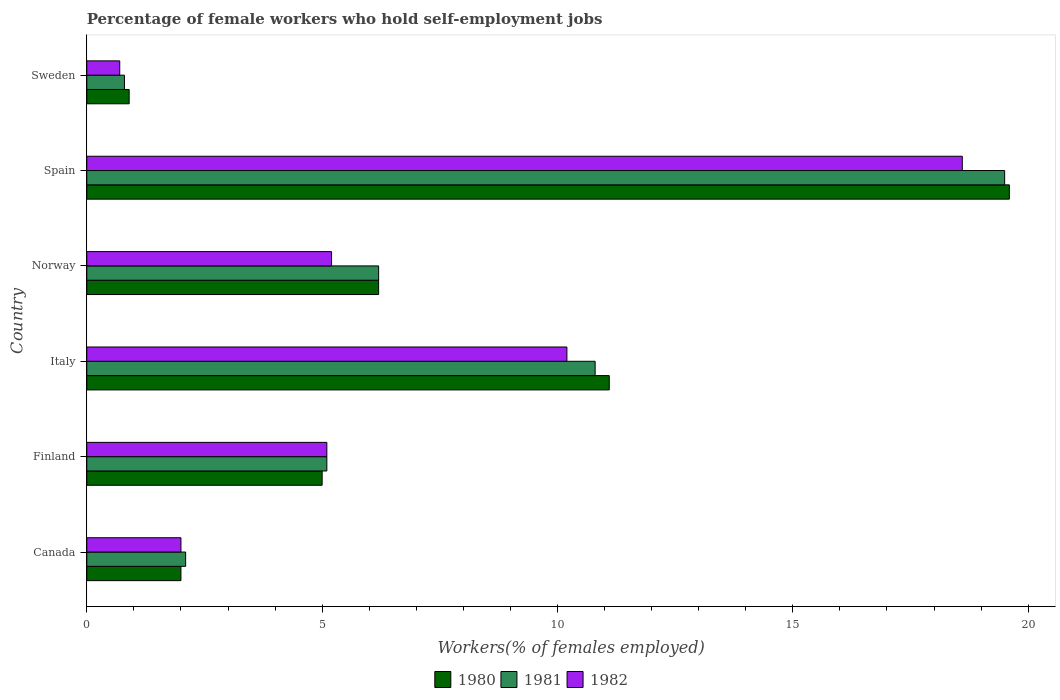How many different coloured bars are there?
Make the answer very short. 3. Are the number of bars per tick equal to the number of legend labels?
Provide a succinct answer. Yes. Are the number of bars on each tick of the Y-axis equal?
Keep it short and to the point. Yes. Across all countries, what is the maximum percentage of self-employed female workers in 1981?
Provide a succinct answer. 19.5. Across all countries, what is the minimum percentage of self-employed female workers in 1980?
Offer a terse response. 0.9. In which country was the percentage of self-employed female workers in 1981 minimum?
Make the answer very short. Sweden. What is the total percentage of self-employed female workers in 1982 in the graph?
Your response must be concise. 41.8. What is the difference between the percentage of self-employed female workers in 1981 in Canada and that in Norway?
Provide a short and direct response. -4.1. What is the difference between the percentage of self-employed female workers in 1980 in Spain and the percentage of self-employed female workers in 1982 in Sweden?
Keep it short and to the point. 18.9. What is the average percentage of self-employed female workers in 1981 per country?
Offer a terse response. 7.42. What is the difference between the percentage of self-employed female workers in 1980 and percentage of self-employed female workers in 1982 in Norway?
Your answer should be very brief. 1. What is the ratio of the percentage of self-employed female workers in 1980 in Norway to that in Spain?
Your answer should be very brief. 0.32. Is the percentage of self-employed female workers in 1980 in Canada less than that in Sweden?
Make the answer very short. No. Is the difference between the percentage of self-employed female workers in 1980 in Norway and Spain greater than the difference between the percentage of self-employed female workers in 1982 in Norway and Spain?
Give a very brief answer. Yes. What is the difference between the highest and the second highest percentage of self-employed female workers in 1982?
Make the answer very short. 8.4. What is the difference between the highest and the lowest percentage of self-employed female workers in 1980?
Your answer should be very brief. 18.7. What does the 1st bar from the top in Finland represents?
Provide a succinct answer. 1982. Is it the case that in every country, the sum of the percentage of self-employed female workers in 1982 and percentage of self-employed female workers in 1980 is greater than the percentage of self-employed female workers in 1981?
Your answer should be very brief. Yes. How many bars are there?
Provide a succinct answer. 18. Are the values on the major ticks of X-axis written in scientific E-notation?
Keep it short and to the point. No. Where does the legend appear in the graph?
Provide a succinct answer. Bottom center. How many legend labels are there?
Make the answer very short. 3. How are the legend labels stacked?
Ensure brevity in your answer.  Horizontal. What is the title of the graph?
Offer a very short reply. Percentage of female workers who hold self-employment jobs. Does "1960" appear as one of the legend labels in the graph?
Your response must be concise. No. What is the label or title of the X-axis?
Give a very brief answer. Workers(% of females employed). What is the Workers(% of females employed) of 1981 in Canada?
Your response must be concise. 2.1. What is the Workers(% of females employed) in 1982 in Canada?
Your response must be concise. 2. What is the Workers(% of females employed) of 1980 in Finland?
Your answer should be compact. 5. What is the Workers(% of females employed) of 1981 in Finland?
Provide a short and direct response. 5.1. What is the Workers(% of females employed) in 1982 in Finland?
Offer a very short reply. 5.1. What is the Workers(% of females employed) of 1980 in Italy?
Your answer should be compact. 11.1. What is the Workers(% of females employed) of 1981 in Italy?
Give a very brief answer. 10.8. What is the Workers(% of females employed) of 1982 in Italy?
Your answer should be compact. 10.2. What is the Workers(% of females employed) of 1980 in Norway?
Ensure brevity in your answer.  6.2. What is the Workers(% of females employed) in 1981 in Norway?
Your answer should be very brief. 6.2. What is the Workers(% of females employed) in 1982 in Norway?
Offer a terse response. 5.2. What is the Workers(% of females employed) of 1980 in Spain?
Provide a short and direct response. 19.6. What is the Workers(% of females employed) in 1982 in Spain?
Your answer should be compact. 18.6. What is the Workers(% of females employed) in 1980 in Sweden?
Your answer should be compact. 0.9. What is the Workers(% of females employed) in 1981 in Sweden?
Provide a succinct answer. 0.8. What is the Workers(% of females employed) in 1982 in Sweden?
Keep it short and to the point. 0.7. Across all countries, what is the maximum Workers(% of females employed) in 1980?
Your answer should be very brief. 19.6. Across all countries, what is the maximum Workers(% of females employed) of 1981?
Give a very brief answer. 19.5. Across all countries, what is the maximum Workers(% of females employed) of 1982?
Your answer should be compact. 18.6. Across all countries, what is the minimum Workers(% of females employed) in 1980?
Give a very brief answer. 0.9. Across all countries, what is the minimum Workers(% of females employed) in 1981?
Provide a succinct answer. 0.8. Across all countries, what is the minimum Workers(% of females employed) of 1982?
Your response must be concise. 0.7. What is the total Workers(% of females employed) in 1980 in the graph?
Ensure brevity in your answer.  44.8. What is the total Workers(% of females employed) in 1981 in the graph?
Give a very brief answer. 44.5. What is the total Workers(% of females employed) of 1982 in the graph?
Give a very brief answer. 41.8. What is the difference between the Workers(% of females employed) of 1980 in Canada and that in Finland?
Provide a short and direct response. -3. What is the difference between the Workers(% of females employed) of 1982 in Canada and that in Finland?
Your answer should be very brief. -3.1. What is the difference between the Workers(% of females employed) of 1980 in Canada and that in Italy?
Ensure brevity in your answer.  -9.1. What is the difference between the Workers(% of females employed) of 1981 in Canada and that in Italy?
Your response must be concise. -8.7. What is the difference between the Workers(% of females employed) of 1982 in Canada and that in Italy?
Ensure brevity in your answer.  -8.2. What is the difference between the Workers(% of females employed) of 1981 in Canada and that in Norway?
Offer a terse response. -4.1. What is the difference between the Workers(% of females employed) in 1980 in Canada and that in Spain?
Your response must be concise. -17.6. What is the difference between the Workers(% of females employed) in 1981 in Canada and that in Spain?
Give a very brief answer. -17.4. What is the difference between the Workers(% of females employed) in 1982 in Canada and that in Spain?
Make the answer very short. -16.6. What is the difference between the Workers(% of females employed) of 1981 in Canada and that in Sweden?
Keep it short and to the point. 1.3. What is the difference between the Workers(% of females employed) of 1982 in Canada and that in Sweden?
Ensure brevity in your answer.  1.3. What is the difference between the Workers(% of females employed) of 1980 in Finland and that in Italy?
Your answer should be compact. -6.1. What is the difference between the Workers(% of females employed) in 1982 in Finland and that in Italy?
Offer a very short reply. -5.1. What is the difference between the Workers(% of females employed) of 1980 in Finland and that in Spain?
Offer a terse response. -14.6. What is the difference between the Workers(% of females employed) of 1981 in Finland and that in Spain?
Your answer should be compact. -14.4. What is the difference between the Workers(% of females employed) in 1982 in Finland and that in Spain?
Provide a short and direct response. -13.5. What is the difference between the Workers(% of females employed) of 1980 in Finland and that in Sweden?
Keep it short and to the point. 4.1. What is the difference between the Workers(% of females employed) in 1982 in Finland and that in Sweden?
Keep it short and to the point. 4.4. What is the difference between the Workers(% of females employed) in 1980 in Italy and that in Norway?
Provide a short and direct response. 4.9. What is the difference between the Workers(% of females employed) in 1981 in Italy and that in Norway?
Provide a short and direct response. 4.6. What is the difference between the Workers(% of females employed) in 1980 in Italy and that in Spain?
Your answer should be very brief. -8.5. What is the difference between the Workers(% of females employed) of 1981 in Italy and that in Spain?
Your response must be concise. -8.7. What is the difference between the Workers(% of females employed) of 1980 in Italy and that in Sweden?
Provide a succinct answer. 10.2. What is the difference between the Workers(% of females employed) of 1982 in Italy and that in Sweden?
Provide a short and direct response. 9.5. What is the difference between the Workers(% of females employed) of 1980 in Norway and that in Spain?
Ensure brevity in your answer.  -13.4. What is the difference between the Workers(% of females employed) in 1981 in Norway and that in Spain?
Your response must be concise. -13.3. What is the difference between the Workers(% of females employed) in 1981 in Spain and that in Sweden?
Your response must be concise. 18.7. What is the difference between the Workers(% of females employed) in 1980 in Canada and the Workers(% of females employed) in 1981 in Finland?
Give a very brief answer. -3.1. What is the difference between the Workers(% of females employed) of 1980 in Canada and the Workers(% of females employed) of 1982 in Finland?
Ensure brevity in your answer.  -3.1. What is the difference between the Workers(% of females employed) of 1981 in Canada and the Workers(% of females employed) of 1982 in Finland?
Keep it short and to the point. -3. What is the difference between the Workers(% of females employed) in 1980 in Canada and the Workers(% of females employed) in 1982 in Italy?
Your response must be concise. -8.2. What is the difference between the Workers(% of females employed) in 1980 in Canada and the Workers(% of females employed) in 1982 in Norway?
Make the answer very short. -3.2. What is the difference between the Workers(% of females employed) in 1981 in Canada and the Workers(% of females employed) in 1982 in Norway?
Provide a succinct answer. -3.1. What is the difference between the Workers(% of females employed) in 1980 in Canada and the Workers(% of females employed) in 1981 in Spain?
Provide a succinct answer. -17.5. What is the difference between the Workers(% of females employed) of 1980 in Canada and the Workers(% of females employed) of 1982 in Spain?
Your answer should be very brief. -16.6. What is the difference between the Workers(% of females employed) of 1981 in Canada and the Workers(% of females employed) of 1982 in Spain?
Ensure brevity in your answer.  -16.5. What is the difference between the Workers(% of females employed) of 1980 in Canada and the Workers(% of females employed) of 1982 in Sweden?
Ensure brevity in your answer.  1.3. What is the difference between the Workers(% of females employed) in 1980 in Finland and the Workers(% of females employed) in 1981 in Italy?
Ensure brevity in your answer.  -5.8. What is the difference between the Workers(% of females employed) of 1980 in Finland and the Workers(% of females employed) of 1982 in Italy?
Provide a short and direct response. -5.2. What is the difference between the Workers(% of females employed) in 1981 in Finland and the Workers(% of females employed) in 1982 in Italy?
Ensure brevity in your answer.  -5.1. What is the difference between the Workers(% of females employed) in 1980 in Finland and the Workers(% of females employed) in 1982 in Norway?
Your response must be concise. -0.2. What is the difference between the Workers(% of females employed) in 1981 in Finland and the Workers(% of females employed) in 1982 in Norway?
Provide a short and direct response. -0.1. What is the difference between the Workers(% of females employed) in 1980 in Finland and the Workers(% of females employed) in 1982 in Sweden?
Keep it short and to the point. 4.3. What is the difference between the Workers(% of females employed) in 1981 in Finland and the Workers(% of females employed) in 1982 in Sweden?
Your answer should be very brief. 4.4. What is the difference between the Workers(% of females employed) of 1980 in Italy and the Workers(% of females employed) of 1981 in Norway?
Offer a terse response. 4.9. What is the difference between the Workers(% of females employed) of 1980 in Italy and the Workers(% of females employed) of 1982 in Norway?
Your answer should be compact. 5.9. What is the difference between the Workers(% of females employed) of 1981 in Italy and the Workers(% of females employed) of 1982 in Norway?
Offer a terse response. 5.6. What is the difference between the Workers(% of females employed) in 1980 in Italy and the Workers(% of females employed) in 1981 in Spain?
Give a very brief answer. -8.4. What is the difference between the Workers(% of females employed) of 1981 in Italy and the Workers(% of females employed) of 1982 in Spain?
Offer a very short reply. -7.8. What is the difference between the Workers(% of females employed) of 1980 in Italy and the Workers(% of females employed) of 1981 in Sweden?
Keep it short and to the point. 10.3. What is the difference between the Workers(% of females employed) in 1980 in Italy and the Workers(% of females employed) in 1982 in Sweden?
Your answer should be very brief. 10.4. What is the difference between the Workers(% of females employed) in 1980 in Norway and the Workers(% of females employed) in 1981 in Spain?
Your answer should be compact. -13.3. What is the difference between the Workers(% of females employed) of 1980 in Spain and the Workers(% of females employed) of 1981 in Sweden?
Provide a short and direct response. 18.8. What is the difference between the Workers(% of females employed) in 1980 in Spain and the Workers(% of females employed) in 1982 in Sweden?
Your answer should be very brief. 18.9. What is the difference between the Workers(% of females employed) in 1981 in Spain and the Workers(% of females employed) in 1982 in Sweden?
Ensure brevity in your answer.  18.8. What is the average Workers(% of females employed) of 1980 per country?
Make the answer very short. 7.47. What is the average Workers(% of females employed) in 1981 per country?
Your response must be concise. 7.42. What is the average Workers(% of females employed) in 1982 per country?
Your answer should be very brief. 6.97. What is the difference between the Workers(% of females employed) of 1980 and Workers(% of females employed) of 1982 in Canada?
Offer a very short reply. 0. What is the difference between the Workers(% of females employed) in 1980 and Workers(% of females employed) in 1982 in Finland?
Offer a terse response. -0.1. What is the difference between the Workers(% of females employed) of 1981 and Workers(% of females employed) of 1982 in Finland?
Your answer should be compact. 0. What is the difference between the Workers(% of females employed) in 1980 and Workers(% of females employed) in 1982 in Italy?
Make the answer very short. 0.9. What is the difference between the Workers(% of females employed) in 1981 and Workers(% of females employed) in 1982 in Italy?
Provide a short and direct response. 0.6. What is the difference between the Workers(% of females employed) in 1981 and Workers(% of females employed) in 1982 in Norway?
Keep it short and to the point. 1. What is the difference between the Workers(% of females employed) in 1980 and Workers(% of females employed) in 1981 in Spain?
Give a very brief answer. 0.1. What is the difference between the Workers(% of females employed) of 1981 and Workers(% of females employed) of 1982 in Spain?
Your answer should be very brief. 0.9. What is the difference between the Workers(% of females employed) of 1980 and Workers(% of females employed) of 1982 in Sweden?
Give a very brief answer. 0.2. What is the ratio of the Workers(% of females employed) of 1980 in Canada to that in Finland?
Make the answer very short. 0.4. What is the ratio of the Workers(% of females employed) of 1981 in Canada to that in Finland?
Offer a very short reply. 0.41. What is the ratio of the Workers(% of females employed) of 1982 in Canada to that in Finland?
Make the answer very short. 0.39. What is the ratio of the Workers(% of females employed) in 1980 in Canada to that in Italy?
Ensure brevity in your answer.  0.18. What is the ratio of the Workers(% of females employed) in 1981 in Canada to that in Italy?
Give a very brief answer. 0.19. What is the ratio of the Workers(% of females employed) in 1982 in Canada to that in Italy?
Your response must be concise. 0.2. What is the ratio of the Workers(% of females employed) of 1980 in Canada to that in Norway?
Provide a succinct answer. 0.32. What is the ratio of the Workers(% of females employed) in 1981 in Canada to that in Norway?
Ensure brevity in your answer.  0.34. What is the ratio of the Workers(% of females employed) in 1982 in Canada to that in Norway?
Make the answer very short. 0.38. What is the ratio of the Workers(% of females employed) of 1980 in Canada to that in Spain?
Provide a succinct answer. 0.1. What is the ratio of the Workers(% of females employed) in 1981 in Canada to that in Spain?
Keep it short and to the point. 0.11. What is the ratio of the Workers(% of females employed) in 1982 in Canada to that in Spain?
Your answer should be compact. 0.11. What is the ratio of the Workers(% of females employed) in 1980 in Canada to that in Sweden?
Ensure brevity in your answer.  2.22. What is the ratio of the Workers(% of females employed) in 1981 in Canada to that in Sweden?
Your answer should be compact. 2.62. What is the ratio of the Workers(% of females employed) of 1982 in Canada to that in Sweden?
Your answer should be compact. 2.86. What is the ratio of the Workers(% of females employed) in 1980 in Finland to that in Italy?
Your response must be concise. 0.45. What is the ratio of the Workers(% of females employed) in 1981 in Finland to that in Italy?
Provide a short and direct response. 0.47. What is the ratio of the Workers(% of females employed) in 1980 in Finland to that in Norway?
Keep it short and to the point. 0.81. What is the ratio of the Workers(% of females employed) of 1981 in Finland to that in Norway?
Keep it short and to the point. 0.82. What is the ratio of the Workers(% of females employed) of 1982 in Finland to that in Norway?
Offer a terse response. 0.98. What is the ratio of the Workers(% of females employed) of 1980 in Finland to that in Spain?
Provide a succinct answer. 0.26. What is the ratio of the Workers(% of females employed) in 1981 in Finland to that in Spain?
Your response must be concise. 0.26. What is the ratio of the Workers(% of females employed) of 1982 in Finland to that in Spain?
Offer a terse response. 0.27. What is the ratio of the Workers(% of females employed) of 1980 in Finland to that in Sweden?
Your answer should be very brief. 5.56. What is the ratio of the Workers(% of females employed) in 1981 in Finland to that in Sweden?
Make the answer very short. 6.38. What is the ratio of the Workers(% of females employed) of 1982 in Finland to that in Sweden?
Your answer should be very brief. 7.29. What is the ratio of the Workers(% of females employed) in 1980 in Italy to that in Norway?
Offer a terse response. 1.79. What is the ratio of the Workers(% of females employed) of 1981 in Italy to that in Norway?
Offer a very short reply. 1.74. What is the ratio of the Workers(% of females employed) of 1982 in Italy to that in Norway?
Ensure brevity in your answer.  1.96. What is the ratio of the Workers(% of females employed) in 1980 in Italy to that in Spain?
Your answer should be compact. 0.57. What is the ratio of the Workers(% of females employed) of 1981 in Italy to that in Spain?
Give a very brief answer. 0.55. What is the ratio of the Workers(% of females employed) in 1982 in Italy to that in Spain?
Your answer should be compact. 0.55. What is the ratio of the Workers(% of females employed) in 1980 in Italy to that in Sweden?
Offer a very short reply. 12.33. What is the ratio of the Workers(% of females employed) in 1982 in Italy to that in Sweden?
Offer a very short reply. 14.57. What is the ratio of the Workers(% of females employed) of 1980 in Norway to that in Spain?
Your answer should be compact. 0.32. What is the ratio of the Workers(% of females employed) in 1981 in Norway to that in Spain?
Provide a short and direct response. 0.32. What is the ratio of the Workers(% of females employed) of 1982 in Norway to that in Spain?
Keep it short and to the point. 0.28. What is the ratio of the Workers(% of females employed) of 1980 in Norway to that in Sweden?
Ensure brevity in your answer.  6.89. What is the ratio of the Workers(% of females employed) in 1981 in Norway to that in Sweden?
Ensure brevity in your answer.  7.75. What is the ratio of the Workers(% of females employed) in 1982 in Norway to that in Sweden?
Your answer should be compact. 7.43. What is the ratio of the Workers(% of females employed) in 1980 in Spain to that in Sweden?
Make the answer very short. 21.78. What is the ratio of the Workers(% of females employed) in 1981 in Spain to that in Sweden?
Your response must be concise. 24.38. What is the ratio of the Workers(% of females employed) of 1982 in Spain to that in Sweden?
Make the answer very short. 26.57. What is the difference between the highest and the lowest Workers(% of females employed) of 1981?
Your answer should be very brief. 18.7. What is the difference between the highest and the lowest Workers(% of females employed) in 1982?
Provide a succinct answer. 17.9. 